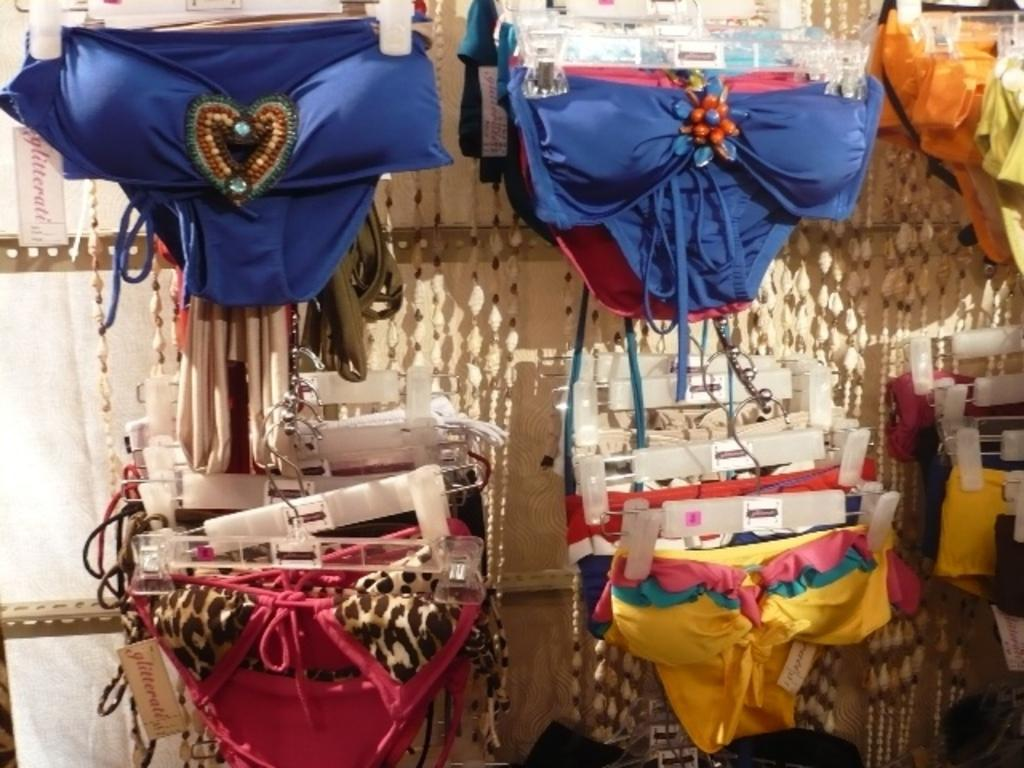What is the main subject of the image? The main subject of the image is a rack of garments in the center. Can you describe the arrangement of the garments? The garments are arranged in a rack in the center of the image. What else can be seen in the background of the image? There is cloth visible in the background of the image. What type of muscle is being flexed by the garments in the image? There are no muscles present in the image, as it features garments arranged in a rack. How does the image convey a sense of hate or dislike? The image does not convey a sense of hate or dislike; it simply shows a rack of garments and cloth in the background. 